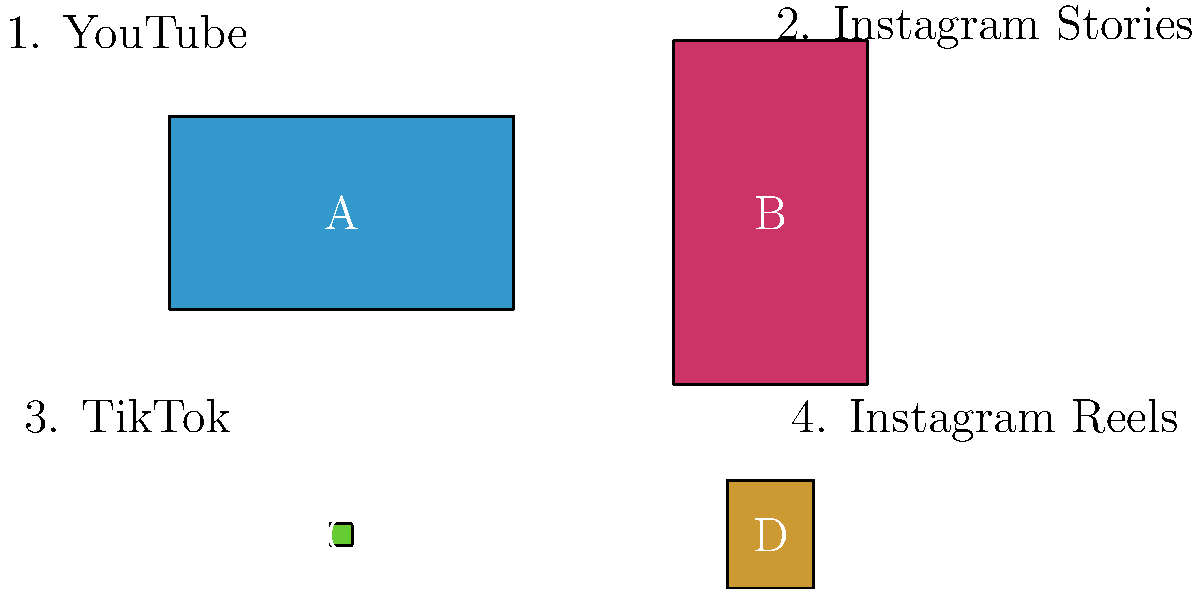As a video editor, match the correct aspect ratios (A, B, C, or D) with the corresponding social media platforms (1, 2, 3, or 4) for optimal video uploads. What is the correct combination? Let's break down the aspect ratios and platforms step-by-step:

1. YouTube:
   - Standard aspect ratio: 16:9 (widescreen)
   - Matches rectangle A

2. Instagram Stories:
   - Vertical format with aspect ratio 9:16
   - Matches rectangle B

3. TikTok:
   - Full-screen vertical videos with aspect ratio 9:16
   - Also matches rectangle B

4. Instagram Reels:
   - Vertical format, typically 9:16 but also supports 4:5
   - Matches rectangle B (9:16) or D (4:5)

Given the options, the most accurate matching is:
1. YouTube - A (16:9)
2. Instagram Stories - B (9:16)
3. TikTok - B (9:16)
4. Instagram Reels - D (4:5)

Note that while TikTok and Instagram Stories both use 9:16, we can't assign B to both. Since Instagram Reels has an alternative option (D), we'll use that for the final answer.
Answer: 1A, 2B, 3B, 4D 